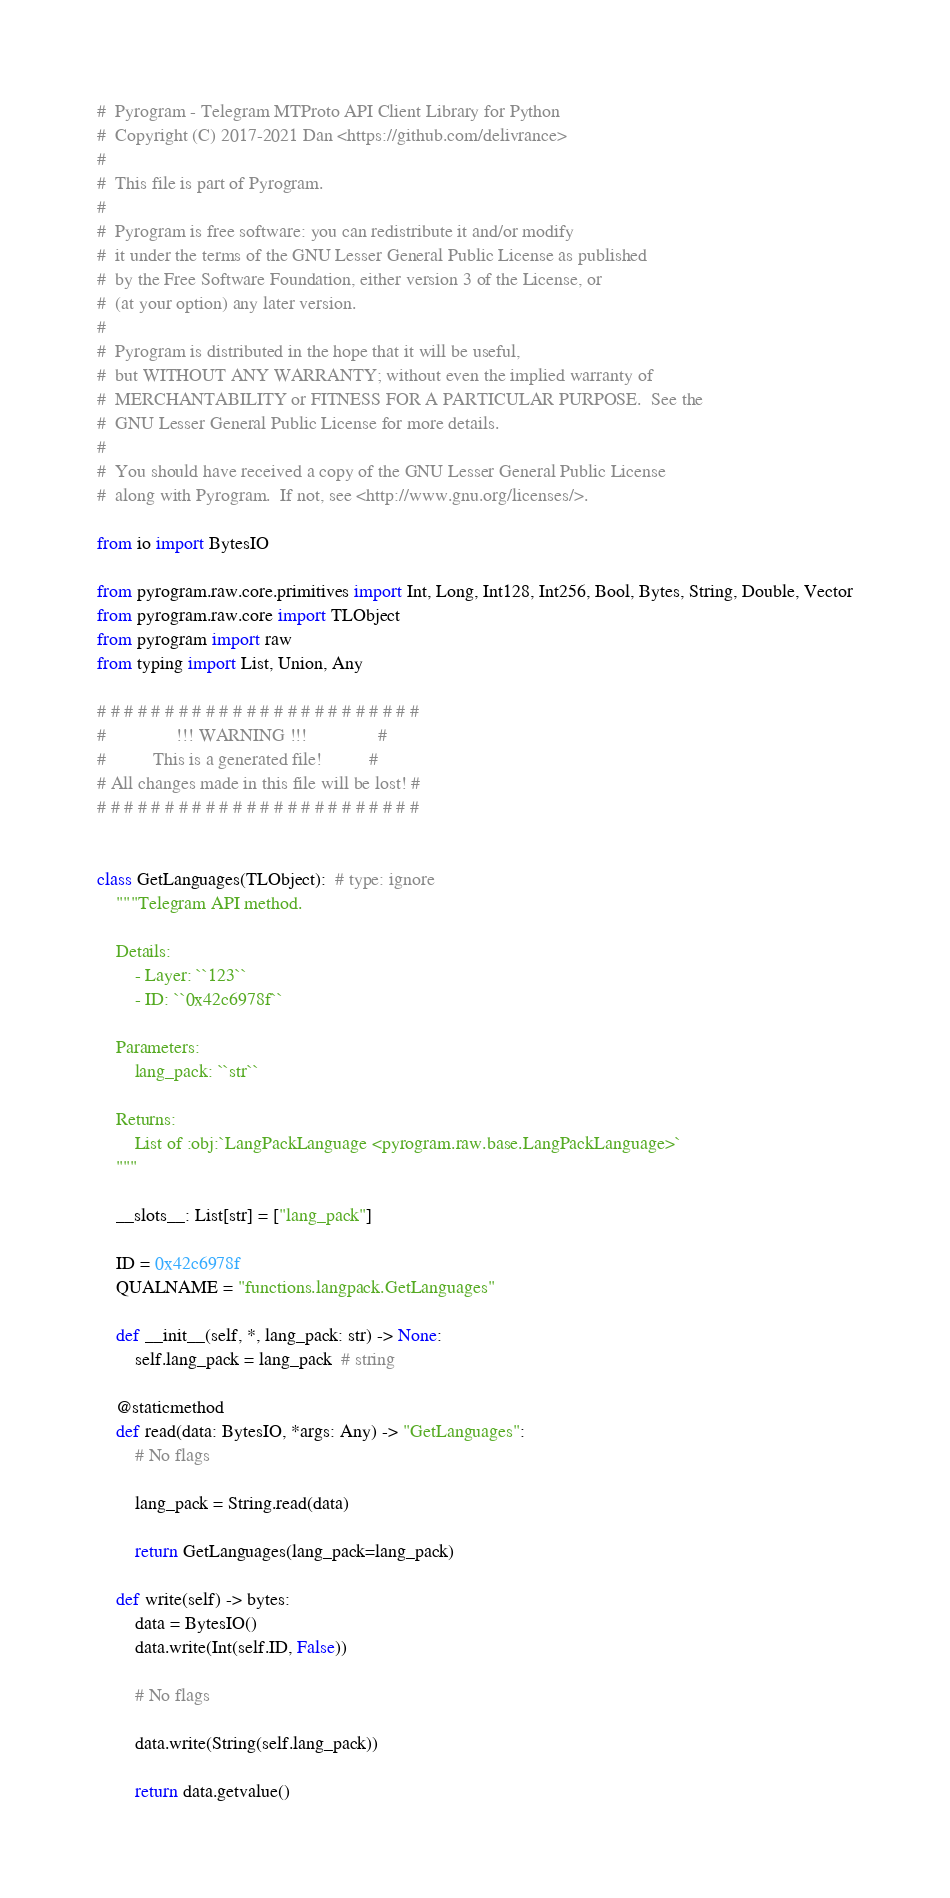Convert code to text. <code><loc_0><loc_0><loc_500><loc_500><_Python_>#  Pyrogram - Telegram MTProto API Client Library for Python
#  Copyright (C) 2017-2021 Dan <https://github.com/delivrance>
#
#  This file is part of Pyrogram.
#
#  Pyrogram is free software: you can redistribute it and/or modify
#  it under the terms of the GNU Lesser General Public License as published
#  by the Free Software Foundation, either version 3 of the License, or
#  (at your option) any later version.
#
#  Pyrogram is distributed in the hope that it will be useful,
#  but WITHOUT ANY WARRANTY; without even the implied warranty of
#  MERCHANTABILITY or FITNESS FOR A PARTICULAR PURPOSE.  See the
#  GNU Lesser General Public License for more details.
#
#  You should have received a copy of the GNU Lesser General Public License
#  along with Pyrogram.  If not, see <http://www.gnu.org/licenses/>.

from io import BytesIO

from pyrogram.raw.core.primitives import Int, Long, Int128, Int256, Bool, Bytes, String, Double, Vector
from pyrogram.raw.core import TLObject
from pyrogram import raw
from typing import List, Union, Any

# # # # # # # # # # # # # # # # # # # # # # # #
#               !!! WARNING !!!               #
#          This is a generated file!          #
# All changes made in this file will be lost! #
# # # # # # # # # # # # # # # # # # # # # # # #


class GetLanguages(TLObject):  # type: ignore
    """Telegram API method.

    Details:
        - Layer: ``123``
        - ID: ``0x42c6978f``

    Parameters:
        lang_pack: ``str``

    Returns:
        List of :obj:`LangPackLanguage <pyrogram.raw.base.LangPackLanguage>`
    """

    __slots__: List[str] = ["lang_pack"]

    ID = 0x42c6978f
    QUALNAME = "functions.langpack.GetLanguages"

    def __init__(self, *, lang_pack: str) -> None:
        self.lang_pack = lang_pack  # string

    @staticmethod
    def read(data: BytesIO, *args: Any) -> "GetLanguages":
        # No flags

        lang_pack = String.read(data)

        return GetLanguages(lang_pack=lang_pack)

    def write(self) -> bytes:
        data = BytesIO()
        data.write(Int(self.ID, False))

        # No flags

        data.write(String(self.lang_pack))

        return data.getvalue()
</code> 